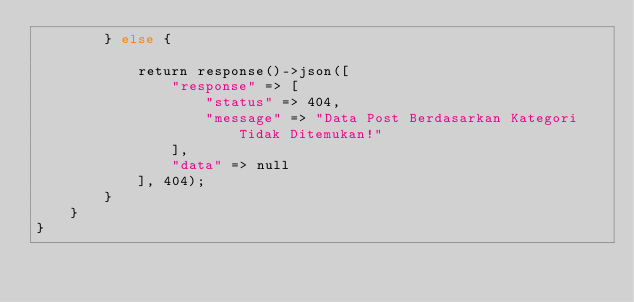Convert code to text. <code><loc_0><loc_0><loc_500><loc_500><_PHP_>        } else {

            return response()->json([
                "response" => [
                    "status" => 404,
                    "message" => "Data Post Berdasarkan Kategori Tidak Ditemukan!"
                ],
                "data" => null
            ], 404);
        }
    }
}
</code> 